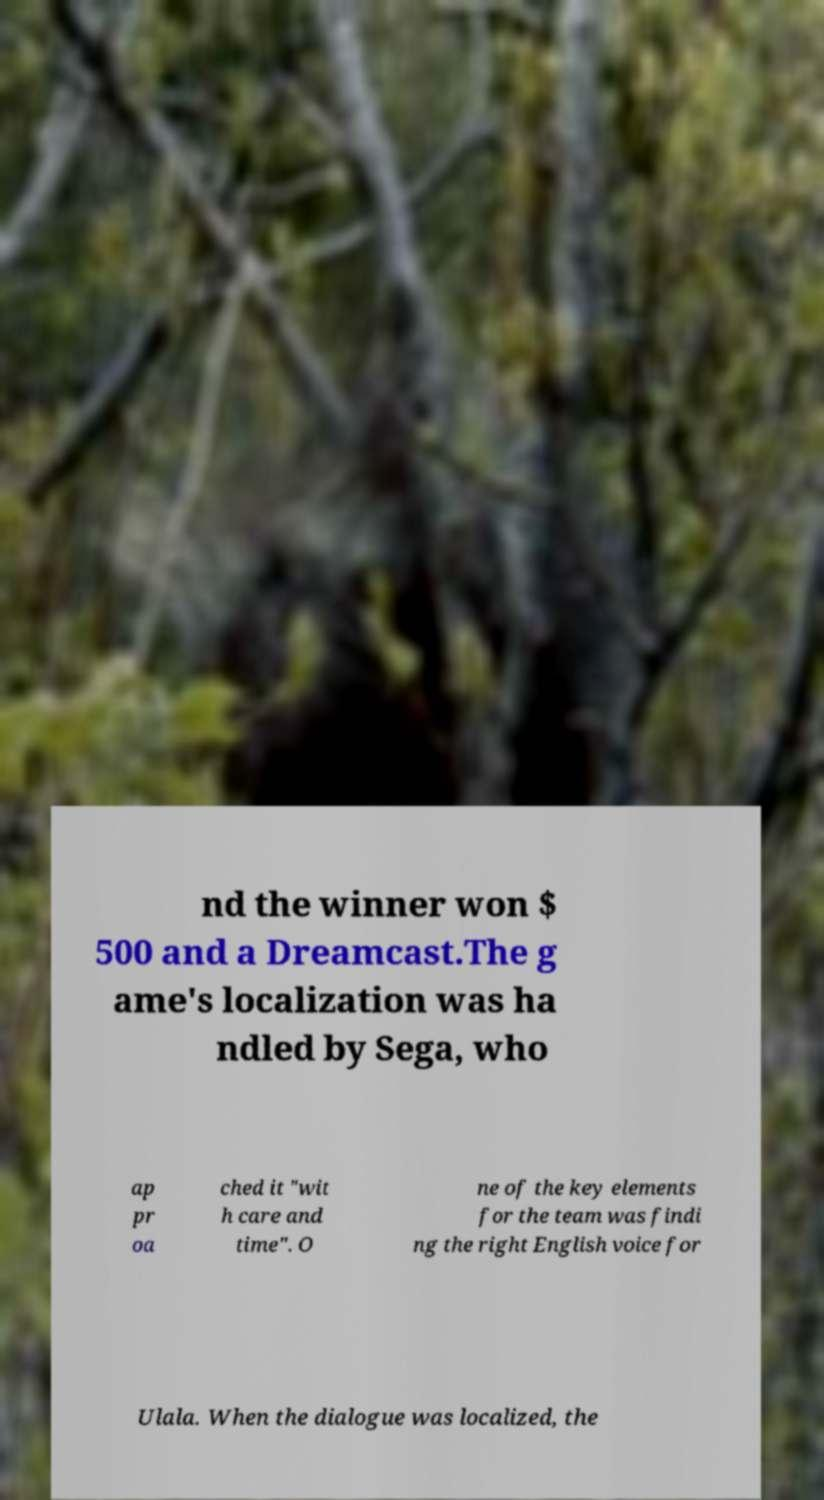Can you accurately transcribe the text from the provided image for me? nd the winner won $ 500 and a Dreamcast.The g ame's localization was ha ndled by Sega, who ap pr oa ched it "wit h care and time". O ne of the key elements for the team was findi ng the right English voice for Ulala. When the dialogue was localized, the 